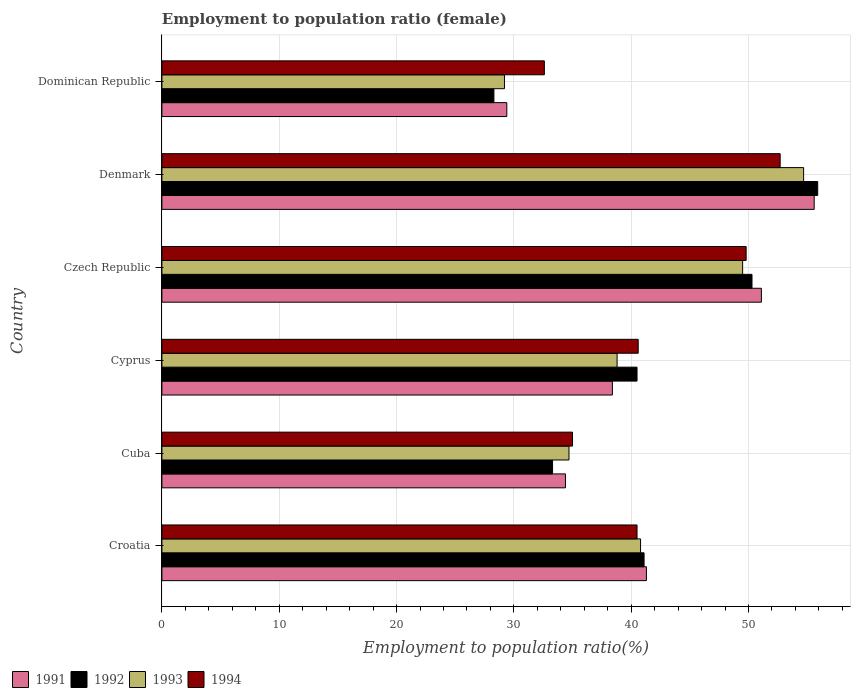How many groups of bars are there?
Keep it short and to the point. 6. Are the number of bars per tick equal to the number of legend labels?
Your answer should be very brief. Yes. Are the number of bars on each tick of the Y-axis equal?
Provide a short and direct response. Yes. How many bars are there on the 4th tick from the bottom?
Make the answer very short. 4. What is the label of the 2nd group of bars from the top?
Your answer should be compact. Denmark. What is the employment to population ratio in 1991 in Denmark?
Offer a terse response. 55.6. Across all countries, what is the maximum employment to population ratio in 1994?
Make the answer very short. 52.7. Across all countries, what is the minimum employment to population ratio in 1992?
Your response must be concise. 28.3. In which country was the employment to population ratio in 1994 minimum?
Offer a very short reply. Dominican Republic. What is the total employment to population ratio in 1992 in the graph?
Your answer should be very brief. 249.4. What is the difference between the employment to population ratio in 1992 in Cuba and that in Czech Republic?
Ensure brevity in your answer.  -17. What is the average employment to population ratio in 1992 per country?
Your answer should be very brief. 41.57. What is the difference between the employment to population ratio in 1993 and employment to population ratio in 1994 in Cyprus?
Keep it short and to the point. -1.8. In how many countries, is the employment to population ratio in 1992 greater than 54 %?
Make the answer very short. 1. What is the ratio of the employment to population ratio in 1993 in Czech Republic to that in Dominican Republic?
Keep it short and to the point. 1.7. What is the difference between the highest and the second highest employment to population ratio in 1994?
Keep it short and to the point. 2.9. What is the difference between the highest and the lowest employment to population ratio in 1993?
Your answer should be compact. 25.5. Is the sum of the employment to population ratio in 1992 in Denmark and Dominican Republic greater than the maximum employment to population ratio in 1991 across all countries?
Provide a succinct answer. Yes. What does the 3rd bar from the top in Cuba represents?
Your answer should be compact. 1992. How many bars are there?
Your response must be concise. 24. How many countries are there in the graph?
Provide a succinct answer. 6. What is the difference between two consecutive major ticks on the X-axis?
Provide a succinct answer. 10. Are the values on the major ticks of X-axis written in scientific E-notation?
Provide a succinct answer. No. Does the graph contain any zero values?
Keep it short and to the point. No. Where does the legend appear in the graph?
Keep it short and to the point. Bottom left. What is the title of the graph?
Your response must be concise. Employment to population ratio (female). Does "1993" appear as one of the legend labels in the graph?
Give a very brief answer. Yes. What is the label or title of the X-axis?
Provide a short and direct response. Employment to population ratio(%). What is the Employment to population ratio(%) in 1991 in Croatia?
Ensure brevity in your answer.  41.3. What is the Employment to population ratio(%) in 1992 in Croatia?
Make the answer very short. 41.1. What is the Employment to population ratio(%) in 1993 in Croatia?
Give a very brief answer. 40.8. What is the Employment to population ratio(%) of 1994 in Croatia?
Provide a short and direct response. 40.5. What is the Employment to population ratio(%) in 1991 in Cuba?
Offer a very short reply. 34.4. What is the Employment to population ratio(%) in 1992 in Cuba?
Make the answer very short. 33.3. What is the Employment to population ratio(%) of 1993 in Cuba?
Offer a very short reply. 34.7. What is the Employment to population ratio(%) in 1991 in Cyprus?
Ensure brevity in your answer.  38.4. What is the Employment to population ratio(%) of 1992 in Cyprus?
Your answer should be compact. 40.5. What is the Employment to population ratio(%) in 1993 in Cyprus?
Offer a terse response. 38.8. What is the Employment to population ratio(%) in 1994 in Cyprus?
Your response must be concise. 40.6. What is the Employment to population ratio(%) in 1991 in Czech Republic?
Keep it short and to the point. 51.1. What is the Employment to population ratio(%) of 1992 in Czech Republic?
Your answer should be very brief. 50.3. What is the Employment to population ratio(%) of 1993 in Czech Republic?
Provide a succinct answer. 49.5. What is the Employment to population ratio(%) in 1994 in Czech Republic?
Ensure brevity in your answer.  49.8. What is the Employment to population ratio(%) of 1991 in Denmark?
Your response must be concise. 55.6. What is the Employment to population ratio(%) in 1992 in Denmark?
Provide a short and direct response. 55.9. What is the Employment to population ratio(%) of 1993 in Denmark?
Provide a short and direct response. 54.7. What is the Employment to population ratio(%) of 1994 in Denmark?
Provide a succinct answer. 52.7. What is the Employment to population ratio(%) in 1991 in Dominican Republic?
Your answer should be compact. 29.4. What is the Employment to population ratio(%) of 1992 in Dominican Republic?
Provide a succinct answer. 28.3. What is the Employment to population ratio(%) of 1993 in Dominican Republic?
Make the answer very short. 29.2. What is the Employment to population ratio(%) in 1994 in Dominican Republic?
Your answer should be compact. 32.6. Across all countries, what is the maximum Employment to population ratio(%) in 1991?
Your answer should be very brief. 55.6. Across all countries, what is the maximum Employment to population ratio(%) in 1992?
Keep it short and to the point. 55.9. Across all countries, what is the maximum Employment to population ratio(%) of 1993?
Your response must be concise. 54.7. Across all countries, what is the maximum Employment to population ratio(%) of 1994?
Offer a terse response. 52.7. Across all countries, what is the minimum Employment to population ratio(%) of 1991?
Ensure brevity in your answer.  29.4. Across all countries, what is the minimum Employment to population ratio(%) in 1992?
Offer a very short reply. 28.3. Across all countries, what is the minimum Employment to population ratio(%) of 1993?
Provide a short and direct response. 29.2. Across all countries, what is the minimum Employment to population ratio(%) of 1994?
Offer a terse response. 32.6. What is the total Employment to population ratio(%) in 1991 in the graph?
Offer a terse response. 250.2. What is the total Employment to population ratio(%) of 1992 in the graph?
Offer a very short reply. 249.4. What is the total Employment to population ratio(%) in 1993 in the graph?
Your answer should be compact. 247.7. What is the total Employment to population ratio(%) of 1994 in the graph?
Offer a terse response. 251.2. What is the difference between the Employment to population ratio(%) of 1991 in Croatia and that in Cuba?
Your answer should be compact. 6.9. What is the difference between the Employment to population ratio(%) of 1992 in Croatia and that in Cuba?
Your answer should be compact. 7.8. What is the difference between the Employment to population ratio(%) in 1993 in Croatia and that in Cuba?
Provide a succinct answer. 6.1. What is the difference between the Employment to population ratio(%) of 1994 in Croatia and that in Cuba?
Your answer should be compact. 5.5. What is the difference between the Employment to population ratio(%) of 1992 in Croatia and that in Cyprus?
Your answer should be compact. 0.6. What is the difference between the Employment to population ratio(%) in 1992 in Croatia and that in Czech Republic?
Offer a terse response. -9.2. What is the difference between the Employment to population ratio(%) in 1993 in Croatia and that in Czech Republic?
Ensure brevity in your answer.  -8.7. What is the difference between the Employment to population ratio(%) of 1994 in Croatia and that in Czech Republic?
Ensure brevity in your answer.  -9.3. What is the difference between the Employment to population ratio(%) in 1991 in Croatia and that in Denmark?
Make the answer very short. -14.3. What is the difference between the Employment to population ratio(%) in 1992 in Croatia and that in Denmark?
Keep it short and to the point. -14.8. What is the difference between the Employment to population ratio(%) in 1993 in Croatia and that in Denmark?
Your answer should be very brief. -13.9. What is the difference between the Employment to population ratio(%) in 1991 in Croatia and that in Dominican Republic?
Provide a succinct answer. 11.9. What is the difference between the Employment to population ratio(%) in 1993 in Croatia and that in Dominican Republic?
Your response must be concise. 11.6. What is the difference between the Employment to population ratio(%) of 1994 in Croatia and that in Dominican Republic?
Offer a very short reply. 7.9. What is the difference between the Employment to population ratio(%) in 1991 in Cuba and that in Cyprus?
Provide a succinct answer. -4. What is the difference between the Employment to population ratio(%) of 1992 in Cuba and that in Cyprus?
Ensure brevity in your answer.  -7.2. What is the difference between the Employment to population ratio(%) in 1993 in Cuba and that in Cyprus?
Provide a short and direct response. -4.1. What is the difference between the Employment to population ratio(%) in 1991 in Cuba and that in Czech Republic?
Provide a succinct answer. -16.7. What is the difference between the Employment to population ratio(%) in 1993 in Cuba and that in Czech Republic?
Your answer should be compact. -14.8. What is the difference between the Employment to population ratio(%) in 1994 in Cuba and that in Czech Republic?
Ensure brevity in your answer.  -14.8. What is the difference between the Employment to population ratio(%) of 1991 in Cuba and that in Denmark?
Your answer should be compact. -21.2. What is the difference between the Employment to population ratio(%) of 1992 in Cuba and that in Denmark?
Your answer should be compact. -22.6. What is the difference between the Employment to population ratio(%) of 1994 in Cuba and that in Denmark?
Offer a very short reply. -17.7. What is the difference between the Employment to population ratio(%) in 1991 in Cuba and that in Dominican Republic?
Provide a short and direct response. 5. What is the difference between the Employment to population ratio(%) of 1992 in Cuba and that in Dominican Republic?
Offer a very short reply. 5. What is the difference between the Employment to population ratio(%) of 1993 in Cuba and that in Dominican Republic?
Provide a succinct answer. 5.5. What is the difference between the Employment to population ratio(%) of 1994 in Cuba and that in Dominican Republic?
Provide a succinct answer. 2.4. What is the difference between the Employment to population ratio(%) of 1991 in Cyprus and that in Czech Republic?
Offer a terse response. -12.7. What is the difference between the Employment to population ratio(%) of 1993 in Cyprus and that in Czech Republic?
Ensure brevity in your answer.  -10.7. What is the difference between the Employment to population ratio(%) of 1994 in Cyprus and that in Czech Republic?
Give a very brief answer. -9.2. What is the difference between the Employment to population ratio(%) in 1991 in Cyprus and that in Denmark?
Offer a terse response. -17.2. What is the difference between the Employment to population ratio(%) of 1992 in Cyprus and that in Denmark?
Ensure brevity in your answer.  -15.4. What is the difference between the Employment to population ratio(%) of 1993 in Cyprus and that in Denmark?
Offer a terse response. -15.9. What is the difference between the Employment to population ratio(%) in 1991 in Cyprus and that in Dominican Republic?
Your answer should be compact. 9. What is the difference between the Employment to population ratio(%) of 1993 in Cyprus and that in Dominican Republic?
Provide a short and direct response. 9.6. What is the difference between the Employment to population ratio(%) in 1994 in Cyprus and that in Dominican Republic?
Keep it short and to the point. 8. What is the difference between the Employment to population ratio(%) in 1991 in Czech Republic and that in Denmark?
Your response must be concise. -4.5. What is the difference between the Employment to population ratio(%) of 1991 in Czech Republic and that in Dominican Republic?
Offer a very short reply. 21.7. What is the difference between the Employment to population ratio(%) of 1992 in Czech Republic and that in Dominican Republic?
Ensure brevity in your answer.  22. What is the difference between the Employment to population ratio(%) in 1993 in Czech Republic and that in Dominican Republic?
Make the answer very short. 20.3. What is the difference between the Employment to population ratio(%) in 1991 in Denmark and that in Dominican Republic?
Your answer should be very brief. 26.2. What is the difference between the Employment to population ratio(%) in 1992 in Denmark and that in Dominican Republic?
Your answer should be compact. 27.6. What is the difference between the Employment to population ratio(%) in 1993 in Denmark and that in Dominican Republic?
Ensure brevity in your answer.  25.5. What is the difference between the Employment to population ratio(%) in 1994 in Denmark and that in Dominican Republic?
Your response must be concise. 20.1. What is the difference between the Employment to population ratio(%) in 1991 in Croatia and the Employment to population ratio(%) in 1992 in Cuba?
Keep it short and to the point. 8. What is the difference between the Employment to population ratio(%) in 1992 in Croatia and the Employment to population ratio(%) in 1993 in Cuba?
Make the answer very short. 6.4. What is the difference between the Employment to population ratio(%) in 1991 in Croatia and the Employment to population ratio(%) in 1993 in Cyprus?
Give a very brief answer. 2.5. What is the difference between the Employment to population ratio(%) in 1992 in Croatia and the Employment to population ratio(%) in 1993 in Cyprus?
Provide a short and direct response. 2.3. What is the difference between the Employment to population ratio(%) of 1991 in Croatia and the Employment to population ratio(%) of 1992 in Czech Republic?
Give a very brief answer. -9. What is the difference between the Employment to population ratio(%) of 1991 in Croatia and the Employment to population ratio(%) of 1993 in Czech Republic?
Ensure brevity in your answer.  -8.2. What is the difference between the Employment to population ratio(%) in 1991 in Croatia and the Employment to population ratio(%) in 1994 in Czech Republic?
Offer a terse response. -8.5. What is the difference between the Employment to population ratio(%) of 1992 in Croatia and the Employment to population ratio(%) of 1993 in Czech Republic?
Keep it short and to the point. -8.4. What is the difference between the Employment to population ratio(%) of 1992 in Croatia and the Employment to population ratio(%) of 1994 in Czech Republic?
Make the answer very short. -8.7. What is the difference between the Employment to population ratio(%) in 1993 in Croatia and the Employment to population ratio(%) in 1994 in Czech Republic?
Give a very brief answer. -9. What is the difference between the Employment to population ratio(%) in 1991 in Croatia and the Employment to population ratio(%) in 1992 in Denmark?
Your answer should be very brief. -14.6. What is the difference between the Employment to population ratio(%) of 1991 in Croatia and the Employment to population ratio(%) of 1992 in Dominican Republic?
Offer a very short reply. 13. What is the difference between the Employment to population ratio(%) of 1991 in Croatia and the Employment to population ratio(%) of 1994 in Dominican Republic?
Keep it short and to the point. 8.7. What is the difference between the Employment to population ratio(%) of 1993 in Croatia and the Employment to population ratio(%) of 1994 in Dominican Republic?
Offer a terse response. 8.2. What is the difference between the Employment to population ratio(%) of 1991 in Cuba and the Employment to population ratio(%) of 1994 in Cyprus?
Your answer should be compact. -6.2. What is the difference between the Employment to population ratio(%) of 1992 in Cuba and the Employment to population ratio(%) of 1993 in Cyprus?
Provide a succinct answer. -5.5. What is the difference between the Employment to population ratio(%) in 1992 in Cuba and the Employment to population ratio(%) in 1994 in Cyprus?
Provide a short and direct response. -7.3. What is the difference between the Employment to population ratio(%) in 1991 in Cuba and the Employment to population ratio(%) in 1992 in Czech Republic?
Your answer should be very brief. -15.9. What is the difference between the Employment to population ratio(%) of 1991 in Cuba and the Employment to population ratio(%) of 1993 in Czech Republic?
Your answer should be compact. -15.1. What is the difference between the Employment to population ratio(%) in 1991 in Cuba and the Employment to population ratio(%) in 1994 in Czech Republic?
Provide a short and direct response. -15.4. What is the difference between the Employment to population ratio(%) of 1992 in Cuba and the Employment to population ratio(%) of 1993 in Czech Republic?
Your answer should be very brief. -16.2. What is the difference between the Employment to population ratio(%) in 1992 in Cuba and the Employment to population ratio(%) in 1994 in Czech Republic?
Keep it short and to the point. -16.5. What is the difference between the Employment to population ratio(%) of 1993 in Cuba and the Employment to population ratio(%) of 1994 in Czech Republic?
Your response must be concise. -15.1. What is the difference between the Employment to population ratio(%) of 1991 in Cuba and the Employment to population ratio(%) of 1992 in Denmark?
Make the answer very short. -21.5. What is the difference between the Employment to population ratio(%) of 1991 in Cuba and the Employment to population ratio(%) of 1993 in Denmark?
Keep it short and to the point. -20.3. What is the difference between the Employment to population ratio(%) in 1991 in Cuba and the Employment to population ratio(%) in 1994 in Denmark?
Offer a very short reply. -18.3. What is the difference between the Employment to population ratio(%) of 1992 in Cuba and the Employment to population ratio(%) of 1993 in Denmark?
Your answer should be compact. -21.4. What is the difference between the Employment to population ratio(%) in 1992 in Cuba and the Employment to population ratio(%) in 1994 in Denmark?
Offer a terse response. -19.4. What is the difference between the Employment to population ratio(%) in 1993 in Cuba and the Employment to population ratio(%) in 1994 in Denmark?
Give a very brief answer. -18. What is the difference between the Employment to population ratio(%) of 1991 in Cuba and the Employment to population ratio(%) of 1994 in Dominican Republic?
Your response must be concise. 1.8. What is the difference between the Employment to population ratio(%) in 1992 in Cuba and the Employment to population ratio(%) in 1993 in Dominican Republic?
Your response must be concise. 4.1. What is the difference between the Employment to population ratio(%) of 1993 in Cuba and the Employment to population ratio(%) of 1994 in Dominican Republic?
Provide a succinct answer. 2.1. What is the difference between the Employment to population ratio(%) in 1991 in Cyprus and the Employment to population ratio(%) in 1993 in Czech Republic?
Ensure brevity in your answer.  -11.1. What is the difference between the Employment to population ratio(%) in 1991 in Cyprus and the Employment to population ratio(%) in 1994 in Czech Republic?
Provide a succinct answer. -11.4. What is the difference between the Employment to population ratio(%) in 1992 in Cyprus and the Employment to population ratio(%) in 1993 in Czech Republic?
Ensure brevity in your answer.  -9. What is the difference between the Employment to population ratio(%) of 1992 in Cyprus and the Employment to population ratio(%) of 1994 in Czech Republic?
Provide a succinct answer. -9.3. What is the difference between the Employment to population ratio(%) in 1993 in Cyprus and the Employment to population ratio(%) in 1994 in Czech Republic?
Give a very brief answer. -11. What is the difference between the Employment to population ratio(%) in 1991 in Cyprus and the Employment to population ratio(%) in 1992 in Denmark?
Make the answer very short. -17.5. What is the difference between the Employment to population ratio(%) in 1991 in Cyprus and the Employment to population ratio(%) in 1993 in Denmark?
Keep it short and to the point. -16.3. What is the difference between the Employment to population ratio(%) in 1991 in Cyprus and the Employment to population ratio(%) in 1994 in Denmark?
Keep it short and to the point. -14.3. What is the difference between the Employment to population ratio(%) of 1992 in Cyprus and the Employment to population ratio(%) of 1993 in Denmark?
Give a very brief answer. -14.2. What is the difference between the Employment to population ratio(%) in 1992 in Cyprus and the Employment to population ratio(%) in 1994 in Denmark?
Your answer should be compact. -12.2. What is the difference between the Employment to population ratio(%) of 1991 in Cyprus and the Employment to population ratio(%) of 1992 in Dominican Republic?
Your answer should be compact. 10.1. What is the difference between the Employment to population ratio(%) of 1991 in Cyprus and the Employment to population ratio(%) of 1993 in Dominican Republic?
Provide a short and direct response. 9.2. What is the difference between the Employment to population ratio(%) in 1992 in Cyprus and the Employment to population ratio(%) in 1993 in Dominican Republic?
Your response must be concise. 11.3. What is the difference between the Employment to population ratio(%) in 1992 in Cyprus and the Employment to population ratio(%) in 1994 in Dominican Republic?
Ensure brevity in your answer.  7.9. What is the difference between the Employment to population ratio(%) of 1991 in Czech Republic and the Employment to population ratio(%) of 1992 in Denmark?
Make the answer very short. -4.8. What is the difference between the Employment to population ratio(%) in 1991 in Czech Republic and the Employment to population ratio(%) in 1994 in Denmark?
Provide a short and direct response. -1.6. What is the difference between the Employment to population ratio(%) in 1993 in Czech Republic and the Employment to population ratio(%) in 1994 in Denmark?
Provide a succinct answer. -3.2. What is the difference between the Employment to population ratio(%) in 1991 in Czech Republic and the Employment to population ratio(%) in 1992 in Dominican Republic?
Provide a short and direct response. 22.8. What is the difference between the Employment to population ratio(%) of 1991 in Czech Republic and the Employment to population ratio(%) of 1993 in Dominican Republic?
Make the answer very short. 21.9. What is the difference between the Employment to population ratio(%) in 1992 in Czech Republic and the Employment to population ratio(%) in 1993 in Dominican Republic?
Ensure brevity in your answer.  21.1. What is the difference between the Employment to population ratio(%) in 1992 in Czech Republic and the Employment to population ratio(%) in 1994 in Dominican Republic?
Your answer should be very brief. 17.7. What is the difference between the Employment to population ratio(%) in 1991 in Denmark and the Employment to population ratio(%) in 1992 in Dominican Republic?
Your response must be concise. 27.3. What is the difference between the Employment to population ratio(%) in 1991 in Denmark and the Employment to population ratio(%) in 1993 in Dominican Republic?
Your answer should be compact. 26.4. What is the difference between the Employment to population ratio(%) in 1991 in Denmark and the Employment to population ratio(%) in 1994 in Dominican Republic?
Keep it short and to the point. 23. What is the difference between the Employment to population ratio(%) in 1992 in Denmark and the Employment to population ratio(%) in 1993 in Dominican Republic?
Offer a terse response. 26.7. What is the difference between the Employment to population ratio(%) in 1992 in Denmark and the Employment to population ratio(%) in 1994 in Dominican Republic?
Provide a succinct answer. 23.3. What is the difference between the Employment to population ratio(%) of 1993 in Denmark and the Employment to population ratio(%) of 1994 in Dominican Republic?
Give a very brief answer. 22.1. What is the average Employment to population ratio(%) of 1991 per country?
Provide a succinct answer. 41.7. What is the average Employment to population ratio(%) in 1992 per country?
Provide a succinct answer. 41.57. What is the average Employment to population ratio(%) of 1993 per country?
Your response must be concise. 41.28. What is the average Employment to population ratio(%) of 1994 per country?
Offer a very short reply. 41.87. What is the difference between the Employment to population ratio(%) in 1992 and Employment to population ratio(%) in 1993 in Croatia?
Make the answer very short. 0.3. What is the difference between the Employment to population ratio(%) of 1991 and Employment to population ratio(%) of 1993 in Cuba?
Offer a terse response. -0.3. What is the difference between the Employment to population ratio(%) of 1992 and Employment to population ratio(%) of 1993 in Cuba?
Your answer should be compact. -1.4. What is the difference between the Employment to population ratio(%) of 1992 and Employment to population ratio(%) of 1994 in Cuba?
Provide a succinct answer. -1.7. What is the difference between the Employment to population ratio(%) of 1991 and Employment to population ratio(%) of 1992 in Cyprus?
Ensure brevity in your answer.  -2.1. What is the difference between the Employment to population ratio(%) of 1991 and Employment to population ratio(%) of 1993 in Cyprus?
Your response must be concise. -0.4. What is the difference between the Employment to population ratio(%) in 1991 and Employment to population ratio(%) in 1994 in Cyprus?
Offer a terse response. -2.2. What is the difference between the Employment to population ratio(%) of 1993 and Employment to population ratio(%) of 1994 in Cyprus?
Offer a terse response. -1.8. What is the difference between the Employment to population ratio(%) of 1991 and Employment to population ratio(%) of 1992 in Czech Republic?
Provide a short and direct response. 0.8. What is the difference between the Employment to population ratio(%) of 1991 and Employment to population ratio(%) of 1994 in Czech Republic?
Offer a very short reply. 1.3. What is the difference between the Employment to population ratio(%) in 1993 and Employment to population ratio(%) in 1994 in Czech Republic?
Your answer should be very brief. -0.3. What is the difference between the Employment to population ratio(%) in 1992 and Employment to population ratio(%) in 1993 in Denmark?
Your answer should be very brief. 1.2. What is the difference between the Employment to population ratio(%) in 1992 and Employment to population ratio(%) in 1994 in Denmark?
Your answer should be very brief. 3.2. What is the difference between the Employment to population ratio(%) in 1993 and Employment to population ratio(%) in 1994 in Denmark?
Keep it short and to the point. 2. What is the difference between the Employment to population ratio(%) in 1991 and Employment to population ratio(%) in 1992 in Dominican Republic?
Offer a very short reply. 1.1. What is the difference between the Employment to population ratio(%) in 1993 and Employment to population ratio(%) in 1994 in Dominican Republic?
Make the answer very short. -3.4. What is the ratio of the Employment to population ratio(%) in 1991 in Croatia to that in Cuba?
Ensure brevity in your answer.  1.2. What is the ratio of the Employment to population ratio(%) of 1992 in Croatia to that in Cuba?
Provide a succinct answer. 1.23. What is the ratio of the Employment to population ratio(%) in 1993 in Croatia to that in Cuba?
Make the answer very short. 1.18. What is the ratio of the Employment to population ratio(%) of 1994 in Croatia to that in Cuba?
Make the answer very short. 1.16. What is the ratio of the Employment to population ratio(%) of 1991 in Croatia to that in Cyprus?
Your answer should be compact. 1.08. What is the ratio of the Employment to population ratio(%) of 1992 in Croatia to that in Cyprus?
Your answer should be compact. 1.01. What is the ratio of the Employment to population ratio(%) of 1993 in Croatia to that in Cyprus?
Ensure brevity in your answer.  1.05. What is the ratio of the Employment to population ratio(%) of 1994 in Croatia to that in Cyprus?
Your response must be concise. 1. What is the ratio of the Employment to population ratio(%) in 1991 in Croatia to that in Czech Republic?
Your answer should be compact. 0.81. What is the ratio of the Employment to population ratio(%) in 1992 in Croatia to that in Czech Republic?
Your answer should be compact. 0.82. What is the ratio of the Employment to population ratio(%) in 1993 in Croatia to that in Czech Republic?
Provide a succinct answer. 0.82. What is the ratio of the Employment to population ratio(%) in 1994 in Croatia to that in Czech Republic?
Make the answer very short. 0.81. What is the ratio of the Employment to population ratio(%) of 1991 in Croatia to that in Denmark?
Ensure brevity in your answer.  0.74. What is the ratio of the Employment to population ratio(%) in 1992 in Croatia to that in Denmark?
Offer a very short reply. 0.74. What is the ratio of the Employment to population ratio(%) in 1993 in Croatia to that in Denmark?
Make the answer very short. 0.75. What is the ratio of the Employment to population ratio(%) of 1994 in Croatia to that in Denmark?
Provide a succinct answer. 0.77. What is the ratio of the Employment to population ratio(%) of 1991 in Croatia to that in Dominican Republic?
Your answer should be very brief. 1.4. What is the ratio of the Employment to population ratio(%) of 1992 in Croatia to that in Dominican Republic?
Your response must be concise. 1.45. What is the ratio of the Employment to population ratio(%) of 1993 in Croatia to that in Dominican Republic?
Your answer should be compact. 1.4. What is the ratio of the Employment to population ratio(%) of 1994 in Croatia to that in Dominican Republic?
Offer a very short reply. 1.24. What is the ratio of the Employment to population ratio(%) of 1991 in Cuba to that in Cyprus?
Offer a terse response. 0.9. What is the ratio of the Employment to population ratio(%) of 1992 in Cuba to that in Cyprus?
Offer a terse response. 0.82. What is the ratio of the Employment to population ratio(%) of 1993 in Cuba to that in Cyprus?
Your answer should be very brief. 0.89. What is the ratio of the Employment to population ratio(%) of 1994 in Cuba to that in Cyprus?
Give a very brief answer. 0.86. What is the ratio of the Employment to population ratio(%) in 1991 in Cuba to that in Czech Republic?
Give a very brief answer. 0.67. What is the ratio of the Employment to population ratio(%) in 1992 in Cuba to that in Czech Republic?
Keep it short and to the point. 0.66. What is the ratio of the Employment to population ratio(%) of 1993 in Cuba to that in Czech Republic?
Offer a terse response. 0.7. What is the ratio of the Employment to population ratio(%) of 1994 in Cuba to that in Czech Republic?
Ensure brevity in your answer.  0.7. What is the ratio of the Employment to population ratio(%) in 1991 in Cuba to that in Denmark?
Offer a very short reply. 0.62. What is the ratio of the Employment to population ratio(%) of 1992 in Cuba to that in Denmark?
Keep it short and to the point. 0.6. What is the ratio of the Employment to population ratio(%) in 1993 in Cuba to that in Denmark?
Your answer should be very brief. 0.63. What is the ratio of the Employment to population ratio(%) in 1994 in Cuba to that in Denmark?
Your response must be concise. 0.66. What is the ratio of the Employment to population ratio(%) in 1991 in Cuba to that in Dominican Republic?
Provide a succinct answer. 1.17. What is the ratio of the Employment to population ratio(%) in 1992 in Cuba to that in Dominican Republic?
Make the answer very short. 1.18. What is the ratio of the Employment to population ratio(%) in 1993 in Cuba to that in Dominican Republic?
Make the answer very short. 1.19. What is the ratio of the Employment to population ratio(%) of 1994 in Cuba to that in Dominican Republic?
Make the answer very short. 1.07. What is the ratio of the Employment to population ratio(%) of 1991 in Cyprus to that in Czech Republic?
Provide a succinct answer. 0.75. What is the ratio of the Employment to population ratio(%) of 1992 in Cyprus to that in Czech Republic?
Provide a short and direct response. 0.81. What is the ratio of the Employment to population ratio(%) of 1993 in Cyprus to that in Czech Republic?
Ensure brevity in your answer.  0.78. What is the ratio of the Employment to population ratio(%) of 1994 in Cyprus to that in Czech Republic?
Your answer should be compact. 0.82. What is the ratio of the Employment to population ratio(%) of 1991 in Cyprus to that in Denmark?
Provide a short and direct response. 0.69. What is the ratio of the Employment to population ratio(%) in 1992 in Cyprus to that in Denmark?
Your response must be concise. 0.72. What is the ratio of the Employment to population ratio(%) in 1993 in Cyprus to that in Denmark?
Keep it short and to the point. 0.71. What is the ratio of the Employment to population ratio(%) of 1994 in Cyprus to that in Denmark?
Offer a terse response. 0.77. What is the ratio of the Employment to population ratio(%) in 1991 in Cyprus to that in Dominican Republic?
Provide a short and direct response. 1.31. What is the ratio of the Employment to population ratio(%) in 1992 in Cyprus to that in Dominican Republic?
Offer a very short reply. 1.43. What is the ratio of the Employment to population ratio(%) in 1993 in Cyprus to that in Dominican Republic?
Make the answer very short. 1.33. What is the ratio of the Employment to population ratio(%) of 1994 in Cyprus to that in Dominican Republic?
Your response must be concise. 1.25. What is the ratio of the Employment to population ratio(%) of 1991 in Czech Republic to that in Denmark?
Ensure brevity in your answer.  0.92. What is the ratio of the Employment to population ratio(%) of 1992 in Czech Republic to that in Denmark?
Your answer should be very brief. 0.9. What is the ratio of the Employment to population ratio(%) of 1993 in Czech Republic to that in Denmark?
Your answer should be very brief. 0.9. What is the ratio of the Employment to population ratio(%) of 1994 in Czech Republic to that in Denmark?
Keep it short and to the point. 0.94. What is the ratio of the Employment to population ratio(%) of 1991 in Czech Republic to that in Dominican Republic?
Make the answer very short. 1.74. What is the ratio of the Employment to population ratio(%) in 1992 in Czech Republic to that in Dominican Republic?
Provide a short and direct response. 1.78. What is the ratio of the Employment to population ratio(%) in 1993 in Czech Republic to that in Dominican Republic?
Ensure brevity in your answer.  1.7. What is the ratio of the Employment to population ratio(%) in 1994 in Czech Republic to that in Dominican Republic?
Provide a short and direct response. 1.53. What is the ratio of the Employment to population ratio(%) in 1991 in Denmark to that in Dominican Republic?
Ensure brevity in your answer.  1.89. What is the ratio of the Employment to population ratio(%) in 1992 in Denmark to that in Dominican Republic?
Your answer should be very brief. 1.98. What is the ratio of the Employment to population ratio(%) in 1993 in Denmark to that in Dominican Republic?
Offer a very short reply. 1.87. What is the ratio of the Employment to population ratio(%) of 1994 in Denmark to that in Dominican Republic?
Your response must be concise. 1.62. What is the difference between the highest and the second highest Employment to population ratio(%) in 1991?
Your answer should be compact. 4.5. What is the difference between the highest and the second highest Employment to population ratio(%) in 1992?
Offer a very short reply. 5.6. What is the difference between the highest and the second highest Employment to population ratio(%) of 1994?
Offer a very short reply. 2.9. What is the difference between the highest and the lowest Employment to population ratio(%) of 1991?
Give a very brief answer. 26.2. What is the difference between the highest and the lowest Employment to population ratio(%) of 1992?
Offer a very short reply. 27.6. What is the difference between the highest and the lowest Employment to population ratio(%) of 1993?
Provide a succinct answer. 25.5. What is the difference between the highest and the lowest Employment to population ratio(%) of 1994?
Provide a succinct answer. 20.1. 